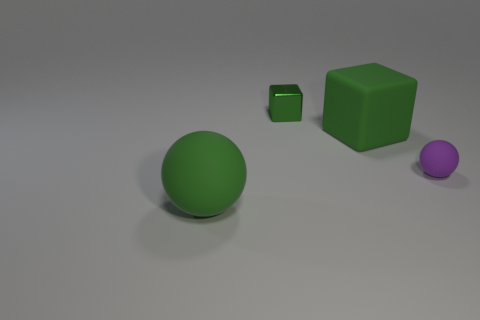Add 4 small green metallic blocks. How many objects exist? 8 Add 3 tiny matte balls. How many tiny matte balls are left? 4 Add 4 big gray rubber cylinders. How many big gray rubber cylinders exist? 4 Subtract 0 brown cubes. How many objects are left? 4 Subtract all big gray matte objects. Subtract all small green blocks. How many objects are left? 3 